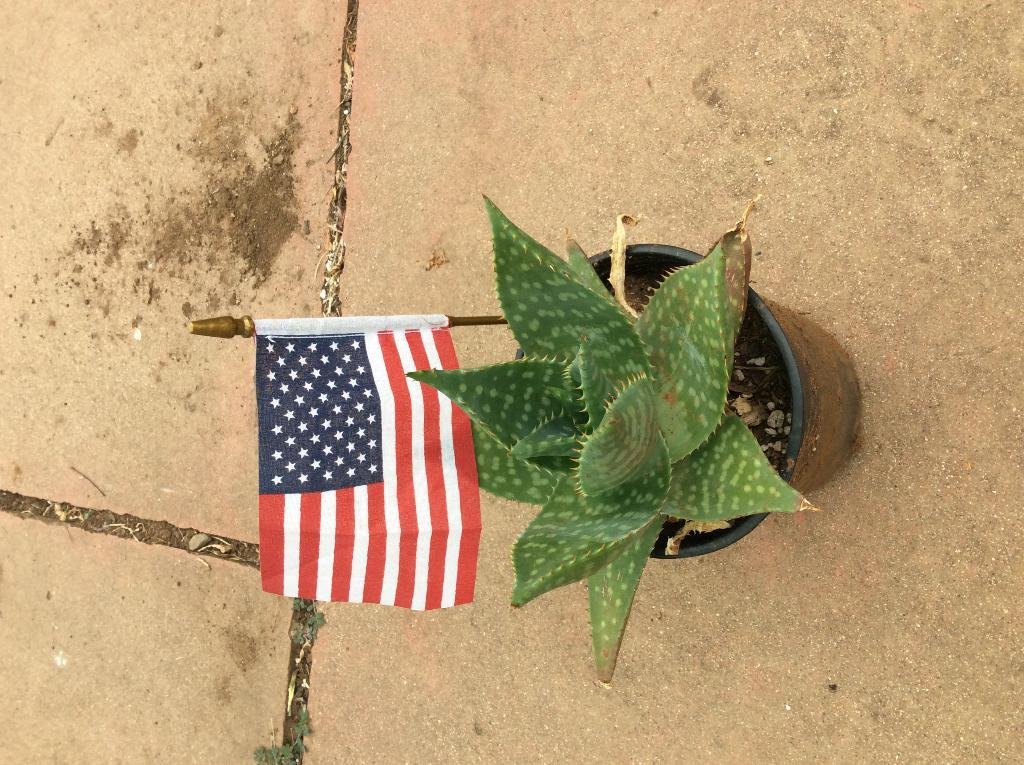What type of plant is in the image? There is a cactus plant in the image. How is the cactus plant contained or displayed? The cactus plant is in a pot. Is there any additional decoration or feature on the pot? Yes, there is a flag on the pot. Where is the pot with the cactus plant located? The pot is on the floor. What type of underwear is visible on the cactus plant in the image? There is no underwear present on the cactus plant in the image. 